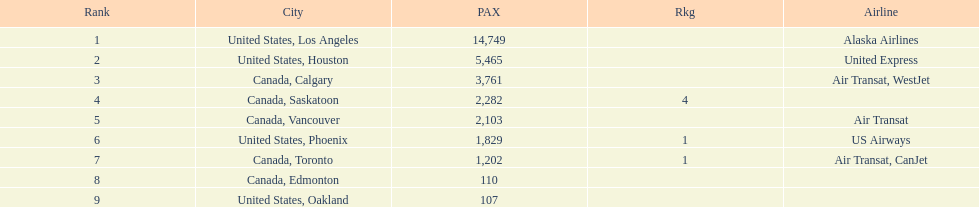How many more passengers flew to los angeles than to saskatoon from manzanillo airport in 2013? 12,467. Can you give me this table as a dict? {'header': ['Rank', 'City', 'PAX', 'Rkg', 'Airline'], 'rows': [['1', 'United States, Los Angeles', '14,749', '', 'Alaska Airlines'], ['2', 'United States, Houston', '5,465', '', 'United Express'], ['3', 'Canada, Calgary', '3,761', '', 'Air Transat, WestJet'], ['4', 'Canada, Saskatoon', '2,282', '4', ''], ['5', 'Canada, Vancouver', '2,103', '', 'Air Transat'], ['6', 'United States, Phoenix', '1,829', '1', 'US Airways'], ['7', 'Canada, Toronto', '1,202', '1', 'Air Transat, CanJet'], ['8', 'Canada, Edmonton', '110', '', ''], ['9', 'United States, Oakland', '107', '', '']]} 